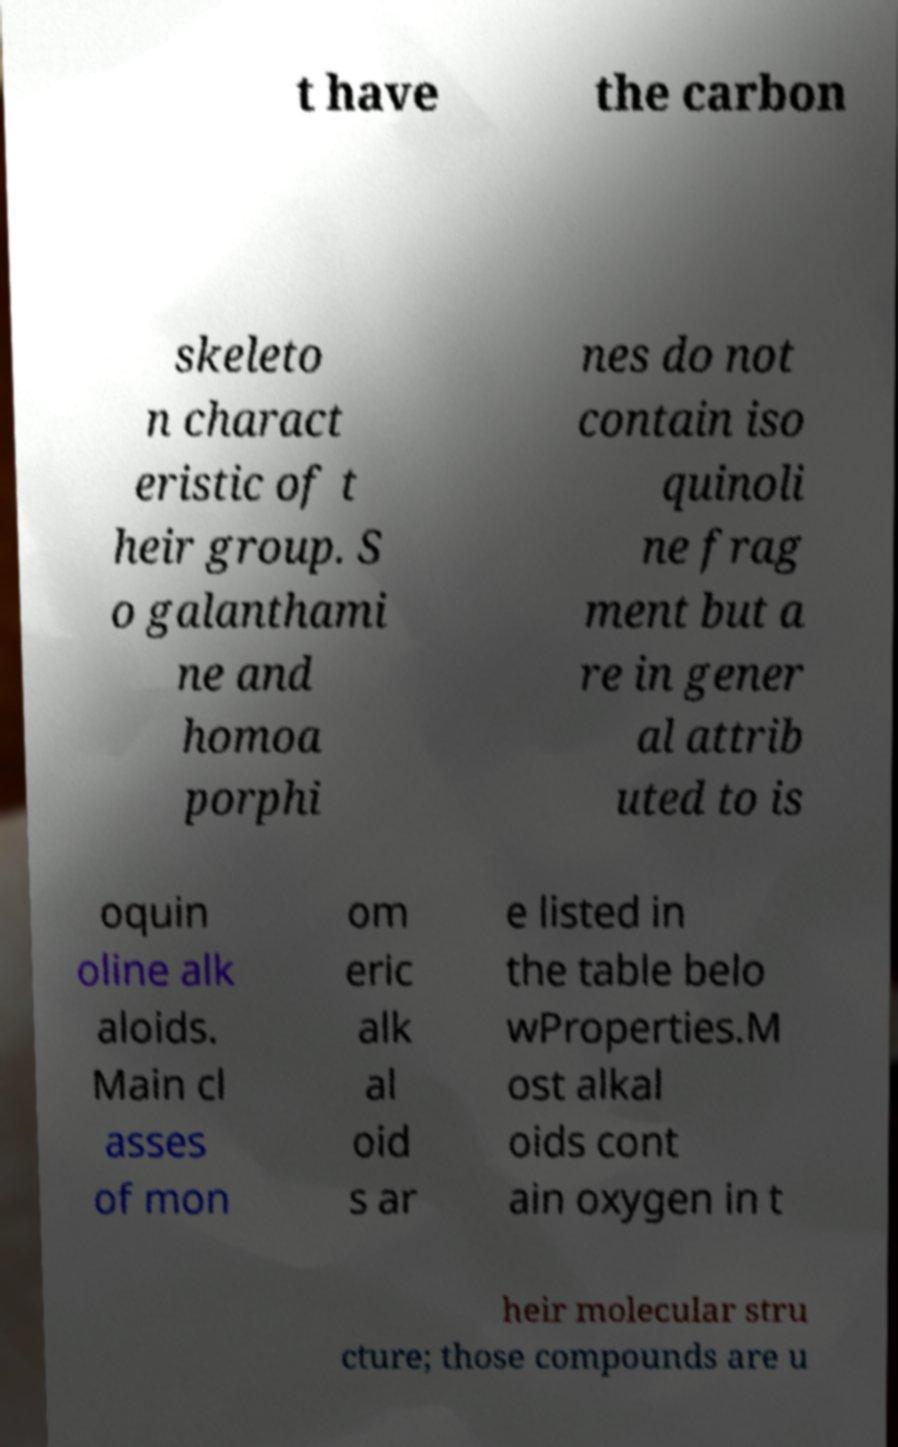Could you extract and type out the text from this image? t have the carbon skeleto n charact eristic of t heir group. S o galanthami ne and homoa porphi nes do not contain iso quinoli ne frag ment but a re in gener al attrib uted to is oquin oline alk aloids. Main cl asses of mon om eric alk al oid s ar e listed in the table belo wProperties.M ost alkal oids cont ain oxygen in t heir molecular stru cture; those compounds are u 